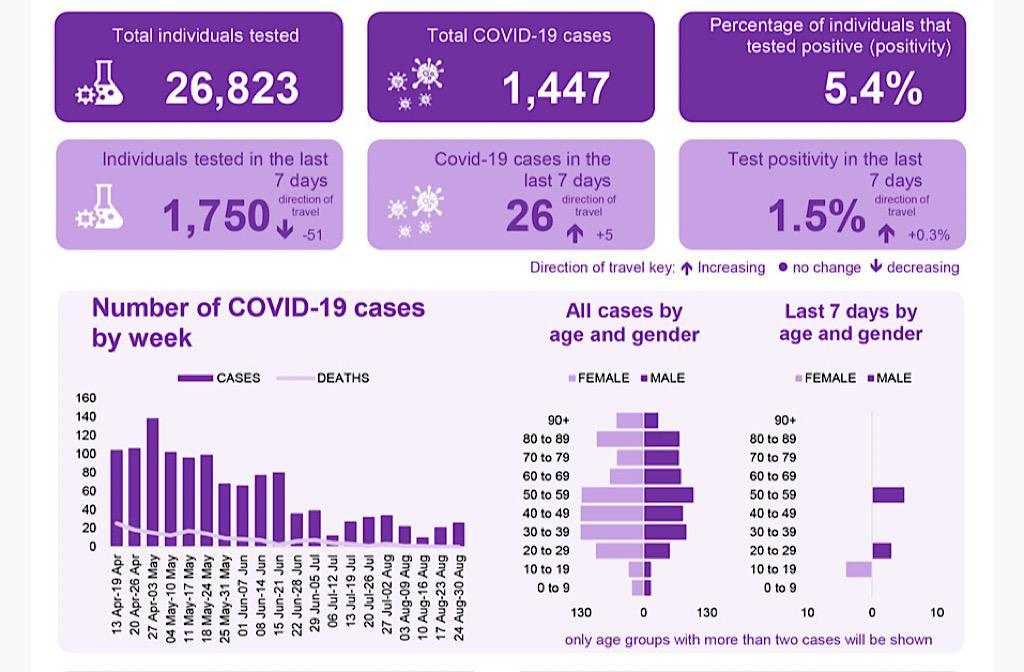How many Covid-19 cases were reported in the last 7 days?
Answer the question with a short phrase. 26 In which week was the number of Covid-19 deaths the highest? 13 Apr -19 Apr What is the direction of travel for, individuals tested in the last 7 days? Decreasing During which week, was the number of covid-19 cases the highest? 27 Apr- 03 May In which two weeks were the number of covid-19 cases lesser than 20? 06 Jul to 12 Jul, 10 Aug to 16 Aug When considering all cases, males in which age group showed the highest cases of covid-19? 50 to 59 By how much has the covid-19 cases in the last 7 days increased? 5 What does the up arrow indicate? Increasing Out of the total individuals tested how many were Covid-19 positive? 1,447 What was the percentage of test positivity in the last 7 days? 1.5% From the total individuals tested, what percentage of individuals tested positive? 5.4% 